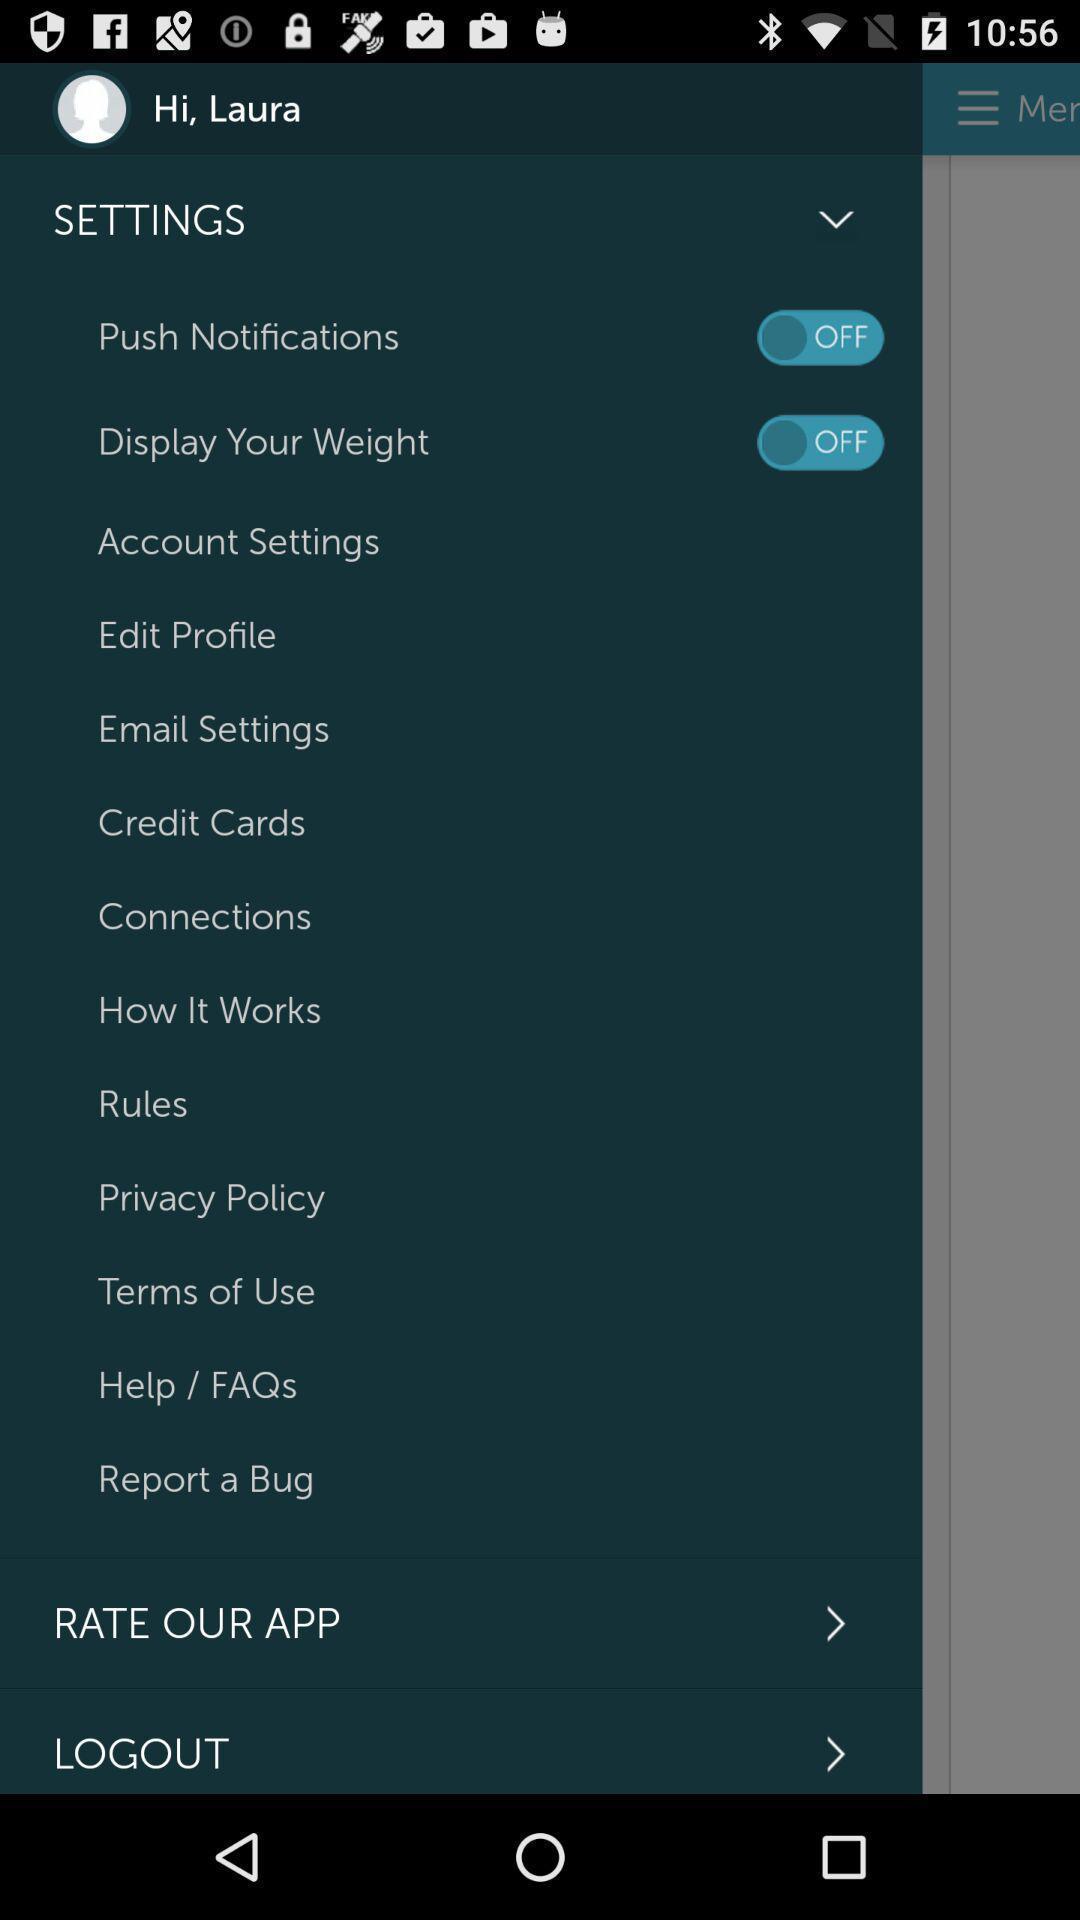Give me a summary of this screen capture. Pop-up showing for settings options. 